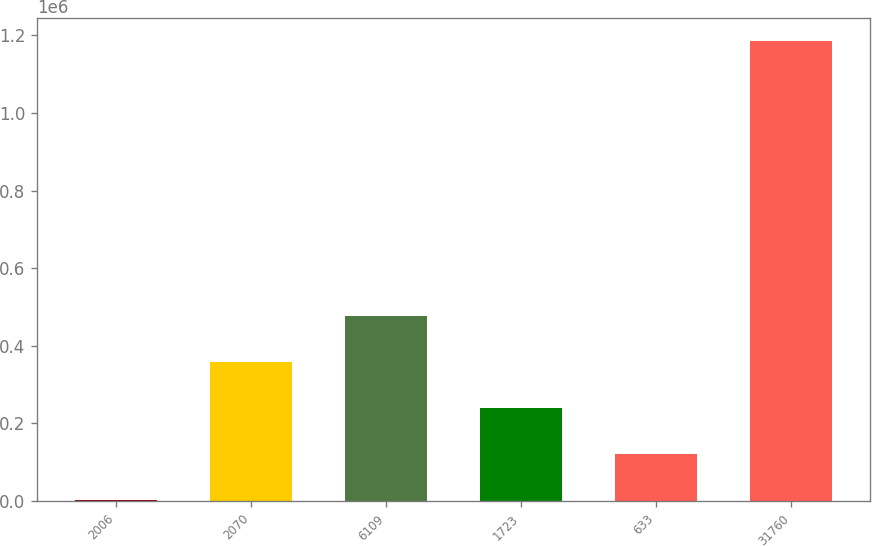Convert chart to OTSL. <chart><loc_0><loc_0><loc_500><loc_500><bar_chart><fcel>2006<fcel>2070<fcel>6109<fcel>1723<fcel>633<fcel>31760<nl><fcel>2005<fcel>356923<fcel>475229<fcel>238617<fcel>120311<fcel>1.18507e+06<nl></chart> 